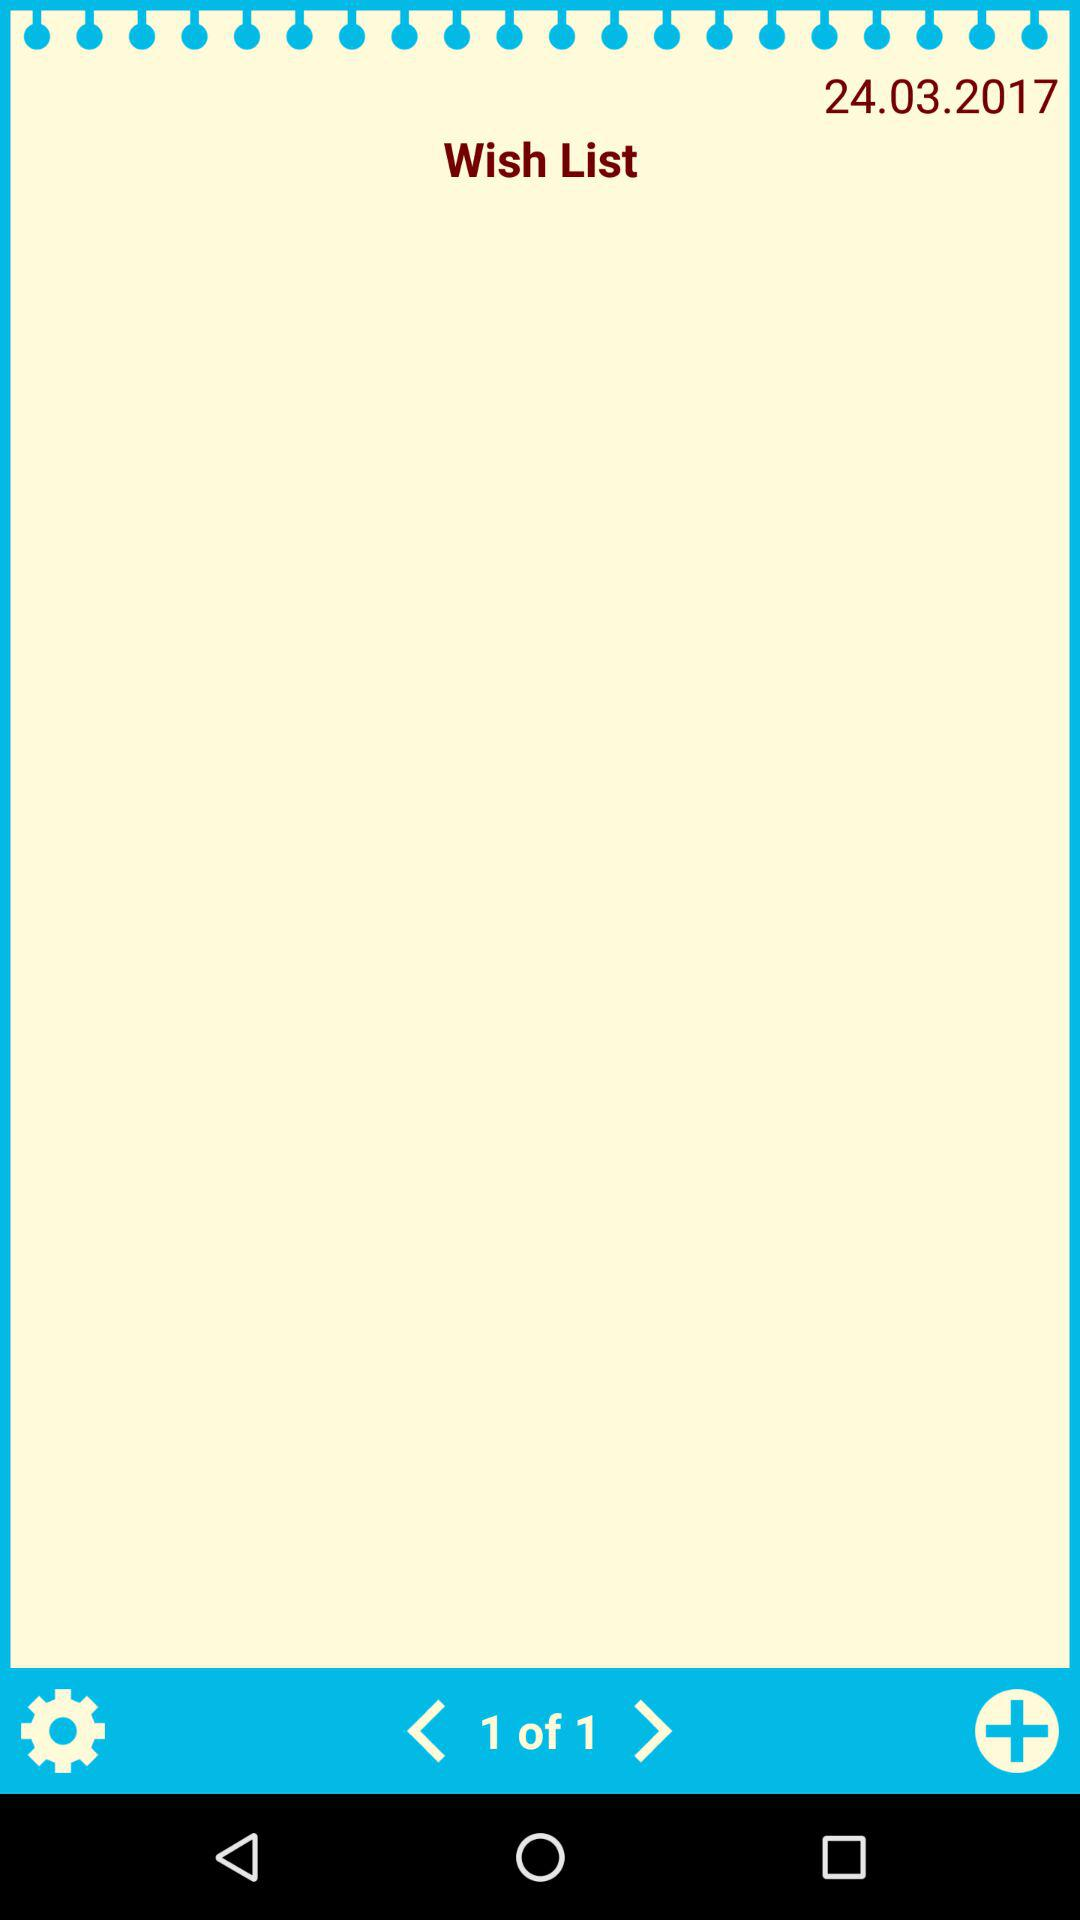What is the given date? The given date is 24.03.2017. 